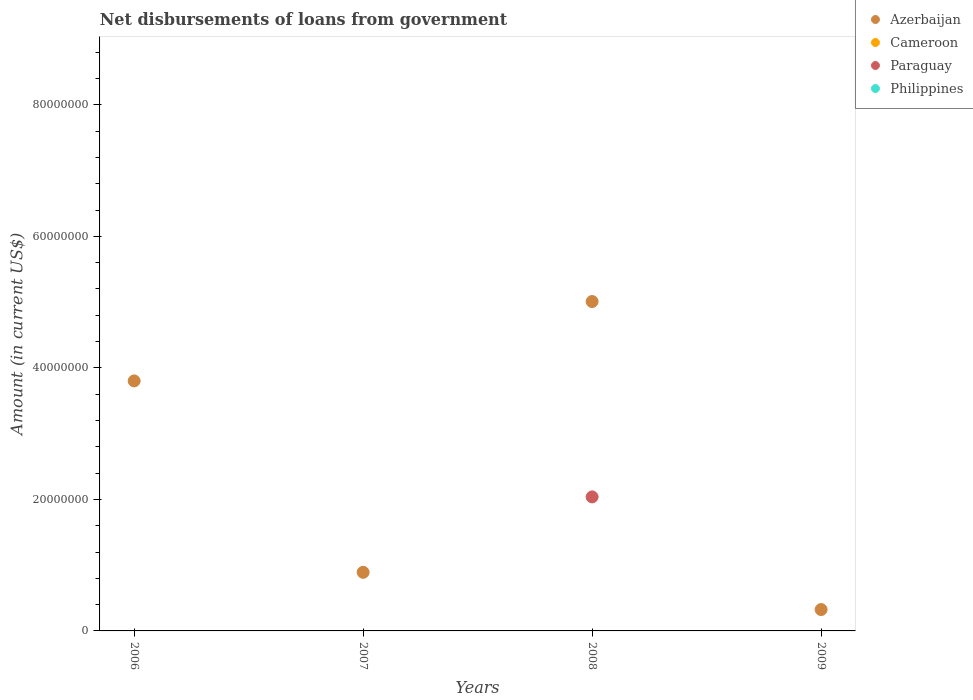How many different coloured dotlines are there?
Make the answer very short. 2. What is the amount of loan disbursed from government in Azerbaijan in 2009?
Your answer should be very brief. 3.25e+06. Across all years, what is the maximum amount of loan disbursed from government in Azerbaijan?
Keep it short and to the point. 5.01e+07. Across all years, what is the minimum amount of loan disbursed from government in Azerbaijan?
Make the answer very short. 3.25e+06. In which year was the amount of loan disbursed from government in Azerbaijan maximum?
Offer a very short reply. 2008. What is the total amount of loan disbursed from government in Philippines in the graph?
Your answer should be very brief. 0. What is the difference between the amount of loan disbursed from government in Azerbaijan in 2007 and that in 2008?
Make the answer very short. -4.12e+07. What is the average amount of loan disbursed from government in Azerbaijan per year?
Your answer should be compact. 2.51e+07. In the year 2008, what is the difference between the amount of loan disbursed from government in Azerbaijan and amount of loan disbursed from government in Paraguay?
Offer a very short reply. 2.97e+07. What is the difference between the highest and the second highest amount of loan disbursed from government in Azerbaijan?
Ensure brevity in your answer.  1.21e+07. What is the difference between the highest and the lowest amount of loan disbursed from government in Paraguay?
Offer a terse response. 2.04e+07. In how many years, is the amount of loan disbursed from government in Cameroon greater than the average amount of loan disbursed from government in Cameroon taken over all years?
Give a very brief answer. 0. Is it the case that in every year, the sum of the amount of loan disbursed from government in Philippines and amount of loan disbursed from government in Cameroon  is greater than the amount of loan disbursed from government in Paraguay?
Give a very brief answer. No. Does the amount of loan disbursed from government in Paraguay monotonically increase over the years?
Offer a very short reply. No. How many dotlines are there?
Your answer should be very brief. 2. Are the values on the major ticks of Y-axis written in scientific E-notation?
Offer a very short reply. No. Does the graph contain grids?
Offer a very short reply. No. How are the legend labels stacked?
Offer a very short reply. Vertical. What is the title of the graph?
Make the answer very short. Net disbursements of loans from government. Does "Heavily indebted poor countries" appear as one of the legend labels in the graph?
Ensure brevity in your answer.  No. What is the label or title of the X-axis?
Provide a succinct answer. Years. What is the label or title of the Y-axis?
Offer a terse response. Amount (in current US$). What is the Amount (in current US$) in Azerbaijan in 2006?
Your answer should be compact. 3.80e+07. What is the Amount (in current US$) in Paraguay in 2006?
Provide a succinct answer. 0. What is the Amount (in current US$) in Azerbaijan in 2007?
Offer a terse response. 8.91e+06. What is the Amount (in current US$) in Cameroon in 2007?
Offer a terse response. 0. What is the Amount (in current US$) of Paraguay in 2007?
Give a very brief answer. 0. What is the Amount (in current US$) of Philippines in 2007?
Your response must be concise. 0. What is the Amount (in current US$) in Azerbaijan in 2008?
Offer a terse response. 5.01e+07. What is the Amount (in current US$) of Cameroon in 2008?
Offer a terse response. 0. What is the Amount (in current US$) in Paraguay in 2008?
Provide a short and direct response. 2.04e+07. What is the Amount (in current US$) of Philippines in 2008?
Your answer should be very brief. 0. What is the Amount (in current US$) of Azerbaijan in 2009?
Provide a short and direct response. 3.25e+06. Across all years, what is the maximum Amount (in current US$) in Azerbaijan?
Your response must be concise. 5.01e+07. Across all years, what is the maximum Amount (in current US$) of Paraguay?
Your answer should be very brief. 2.04e+07. Across all years, what is the minimum Amount (in current US$) of Azerbaijan?
Your response must be concise. 3.25e+06. What is the total Amount (in current US$) in Azerbaijan in the graph?
Keep it short and to the point. 1.00e+08. What is the total Amount (in current US$) of Cameroon in the graph?
Keep it short and to the point. 0. What is the total Amount (in current US$) of Paraguay in the graph?
Provide a short and direct response. 2.04e+07. What is the total Amount (in current US$) of Philippines in the graph?
Your answer should be very brief. 0. What is the difference between the Amount (in current US$) in Azerbaijan in 2006 and that in 2007?
Your answer should be very brief. 2.91e+07. What is the difference between the Amount (in current US$) of Azerbaijan in 2006 and that in 2008?
Offer a very short reply. -1.21e+07. What is the difference between the Amount (in current US$) of Azerbaijan in 2006 and that in 2009?
Your answer should be compact. 3.48e+07. What is the difference between the Amount (in current US$) of Azerbaijan in 2007 and that in 2008?
Ensure brevity in your answer.  -4.12e+07. What is the difference between the Amount (in current US$) of Azerbaijan in 2007 and that in 2009?
Provide a succinct answer. 5.66e+06. What is the difference between the Amount (in current US$) in Azerbaijan in 2008 and that in 2009?
Offer a very short reply. 4.68e+07. What is the difference between the Amount (in current US$) of Azerbaijan in 2006 and the Amount (in current US$) of Paraguay in 2008?
Make the answer very short. 1.76e+07. What is the difference between the Amount (in current US$) in Azerbaijan in 2007 and the Amount (in current US$) in Paraguay in 2008?
Your response must be concise. -1.15e+07. What is the average Amount (in current US$) in Azerbaijan per year?
Your response must be concise. 2.51e+07. What is the average Amount (in current US$) in Cameroon per year?
Your answer should be very brief. 0. What is the average Amount (in current US$) of Paraguay per year?
Make the answer very short. 5.10e+06. What is the average Amount (in current US$) of Philippines per year?
Provide a succinct answer. 0. In the year 2008, what is the difference between the Amount (in current US$) in Azerbaijan and Amount (in current US$) in Paraguay?
Make the answer very short. 2.97e+07. What is the ratio of the Amount (in current US$) in Azerbaijan in 2006 to that in 2007?
Give a very brief answer. 4.27. What is the ratio of the Amount (in current US$) in Azerbaijan in 2006 to that in 2008?
Your answer should be very brief. 0.76. What is the ratio of the Amount (in current US$) in Azerbaijan in 2006 to that in 2009?
Offer a terse response. 11.69. What is the ratio of the Amount (in current US$) in Azerbaijan in 2007 to that in 2008?
Give a very brief answer. 0.18. What is the ratio of the Amount (in current US$) of Azerbaijan in 2007 to that in 2009?
Your answer should be very brief. 2.74. What is the ratio of the Amount (in current US$) in Azerbaijan in 2008 to that in 2009?
Your response must be concise. 15.41. What is the difference between the highest and the second highest Amount (in current US$) in Azerbaijan?
Provide a short and direct response. 1.21e+07. What is the difference between the highest and the lowest Amount (in current US$) in Azerbaijan?
Give a very brief answer. 4.68e+07. What is the difference between the highest and the lowest Amount (in current US$) in Paraguay?
Your answer should be compact. 2.04e+07. 